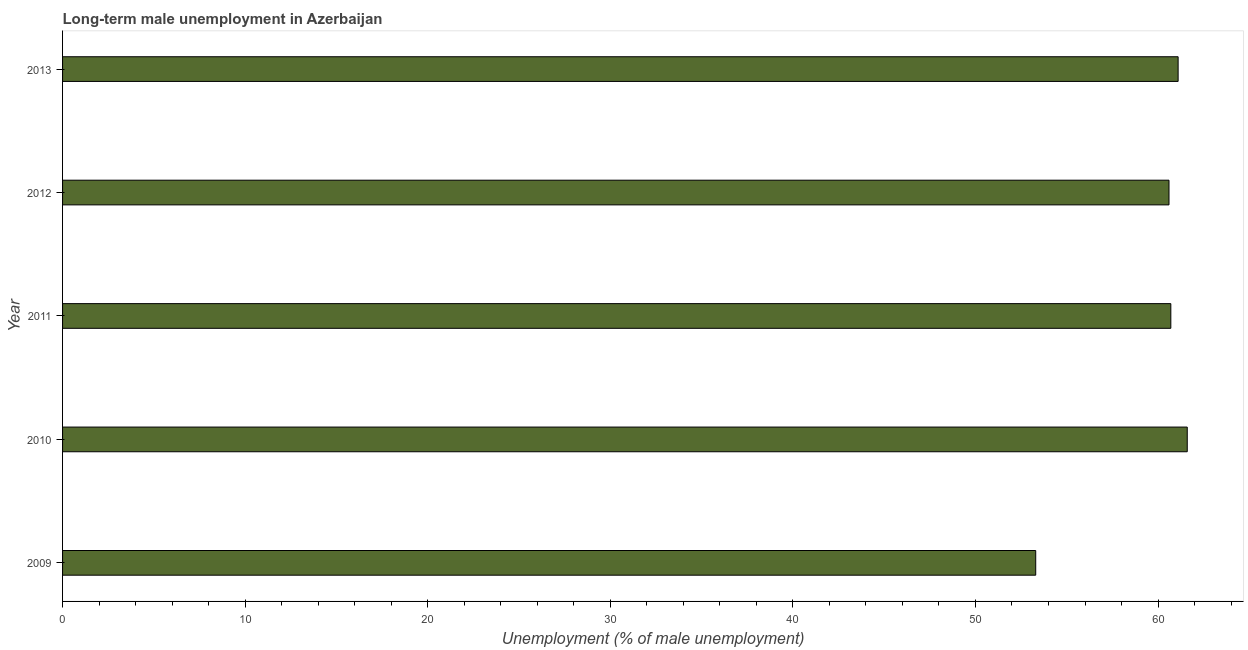What is the title of the graph?
Provide a succinct answer. Long-term male unemployment in Azerbaijan. What is the label or title of the X-axis?
Your answer should be very brief. Unemployment (% of male unemployment). What is the label or title of the Y-axis?
Keep it short and to the point. Year. What is the long-term male unemployment in 2012?
Provide a short and direct response. 60.6. Across all years, what is the maximum long-term male unemployment?
Give a very brief answer. 61.6. Across all years, what is the minimum long-term male unemployment?
Offer a terse response. 53.3. In which year was the long-term male unemployment minimum?
Make the answer very short. 2009. What is the sum of the long-term male unemployment?
Provide a succinct answer. 297.3. What is the average long-term male unemployment per year?
Ensure brevity in your answer.  59.46. What is the median long-term male unemployment?
Ensure brevity in your answer.  60.7. In how many years, is the long-term male unemployment greater than 36 %?
Provide a short and direct response. 5. What is the ratio of the long-term male unemployment in 2009 to that in 2011?
Provide a short and direct response. 0.88. Is the sum of the long-term male unemployment in 2012 and 2013 greater than the maximum long-term male unemployment across all years?
Give a very brief answer. Yes. How many bars are there?
Ensure brevity in your answer.  5. Are all the bars in the graph horizontal?
Make the answer very short. Yes. How many years are there in the graph?
Provide a short and direct response. 5. Are the values on the major ticks of X-axis written in scientific E-notation?
Offer a terse response. No. What is the Unemployment (% of male unemployment) in 2009?
Your answer should be compact. 53.3. What is the Unemployment (% of male unemployment) in 2010?
Provide a short and direct response. 61.6. What is the Unemployment (% of male unemployment) of 2011?
Offer a very short reply. 60.7. What is the Unemployment (% of male unemployment) of 2012?
Make the answer very short. 60.6. What is the Unemployment (% of male unemployment) of 2013?
Your response must be concise. 61.1. What is the difference between the Unemployment (% of male unemployment) in 2009 and 2011?
Ensure brevity in your answer.  -7.4. What is the difference between the Unemployment (% of male unemployment) in 2009 and 2013?
Provide a short and direct response. -7.8. What is the difference between the Unemployment (% of male unemployment) in 2010 and 2012?
Offer a very short reply. 1. What is the difference between the Unemployment (% of male unemployment) in 2011 and 2012?
Your answer should be compact. 0.1. What is the difference between the Unemployment (% of male unemployment) in 2011 and 2013?
Provide a succinct answer. -0.4. What is the ratio of the Unemployment (% of male unemployment) in 2009 to that in 2010?
Your answer should be compact. 0.86. What is the ratio of the Unemployment (% of male unemployment) in 2009 to that in 2011?
Give a very brief answer. 0.88. What is the ratio of the Unemployment (% of male unemployment) in 2009 to that in 2012?
Offer a very short reply. 0.88. What is the ratio of the Unemployment (% of male unemployment) in 2009 to that in 2013?
Your response must be concise. 0.87. What is the ratio of the Unemployment (% of male unemployment) in 2010 to that in 2013?
Your answer should be compact. 1.01. What is the ratio of the Unemployment (% of male unemployment) in 2011 to that in 2012?
Your answer should be very brief. 1. What is the ratio of the Unemployment (% of male unemployment) in 2011 to that in 2013?
Provide a succinct answer. 0.99. 